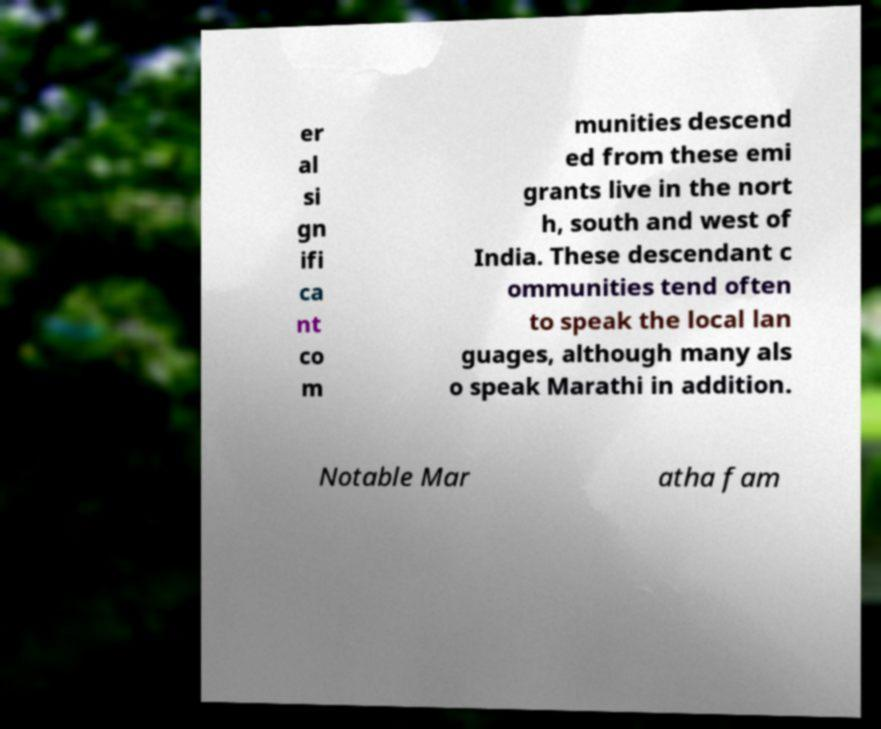For documentation purposes, I need the text within this image transcribed. Could you provide that? er al si gn ifi ca nt co m munities descend ed from these emi grants live in the nort h, south and west of India. These descendant c ommunities tend often to speak the local lan guages, although many als o speak Marathi in addition. Notable Mar atha fam 